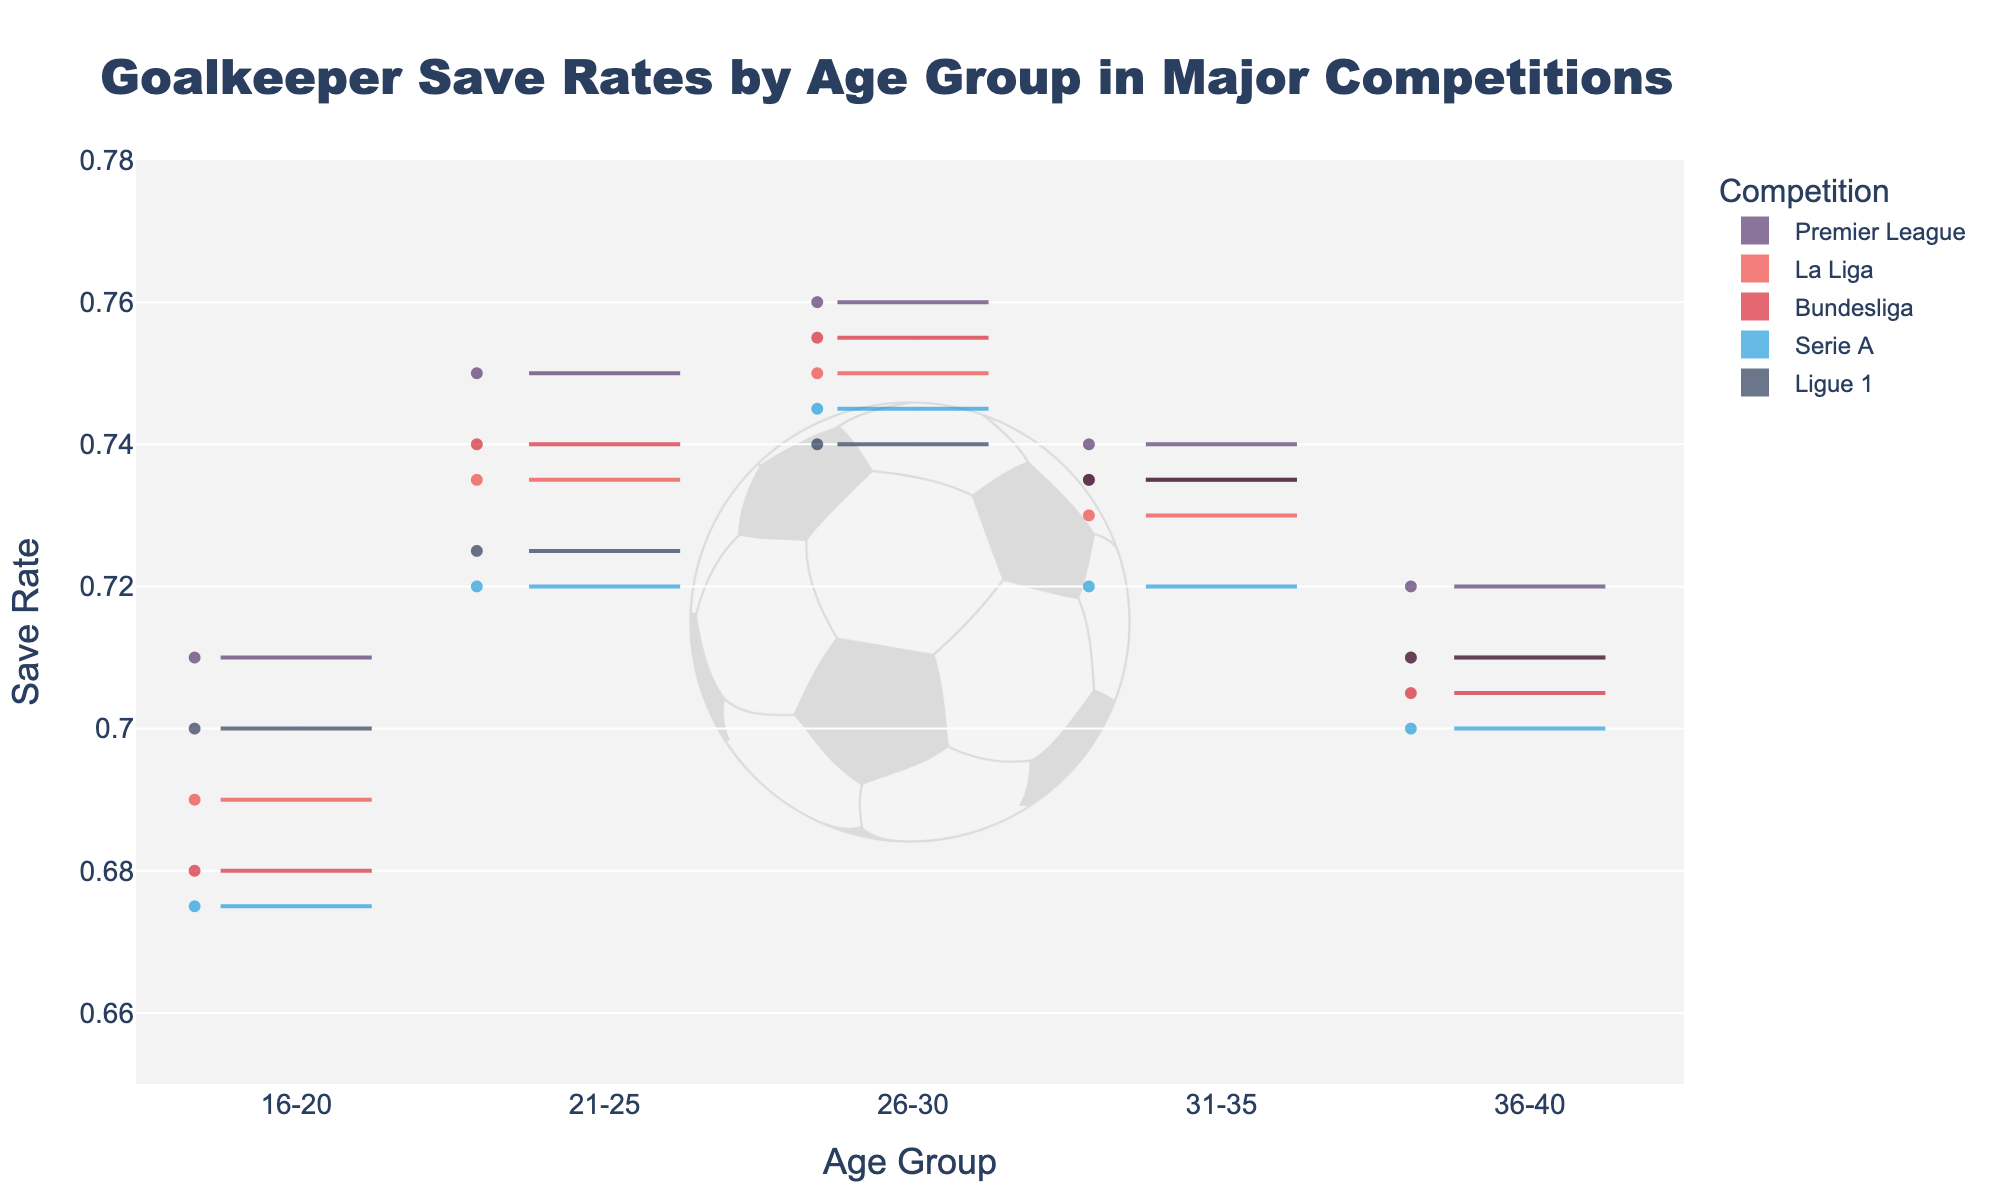What is the title of the figure? The title of the figure is located at the top center of the plot and provides a summary of what the plot represents. The text is bold and larger in size compared to other text elements.
Answer: Goalkeeper Save Rates by Age Group in Major Competitions What does the x-axis represent? The x-axis runs horizontally and is labeled towards the bottom of the plot, displaying different categories for grouping.
Answer: Age Group Which competition has the highest save rate in the age group 16-20? To find the highest save rate for the 16-20 age group, look at the points and meanlines within the 16-20 category and compare them across competitions.
Answer: Premier League What is the range of the y-axis? The y-axis runs vertically and is labeled along the left side of the plot. It shows the full scale of values represented in the plot, which can be seen in the y-axis ticks.
Answer: 0.65 to 0.78 How does the save rate trend differ between the 26-30 age group and the 36-40 age group for Premier League? Look at the Premier League violin plots for the age groups 26-30 and 36-40 and compare the central tendency (meanline) and distribution (spread of points).
Answer: 26-30 has higher save rates Which age group shows the most variability in save rates for Bundesliga? Variability can be assessed by looking at the spread of the data points in the violin plots for each age group in the Bundesliga category. The more spread out the points, the higher the variability.
Answer: 16-20 In which age group does Serie A show a higher save rate: 21-25 or 31-35? Compare the meanlines and points of the Serie A violin plots for the 21-25 and 31-35 age groups. The group with the higher meanline indicates a higher save rate.
Answer: 21-25 Which two age groups have the closest mean save rates for La Liga? Examine the meanlines for La Liga across all age groups. Identify which two meanlines are closest in value.
Answer: 31-35 and 36-40 Does Ligue 1 show an increasing or decreasing trend in save rates from age group 16-20 to 36-40? Observe the progression of meanlines in the Ligue 1 violin plots, from the left (younger age groups) to the right (older age groups), to determine if the save rates are generally increasing or decreasing.
Answer: Decreasing Which competition has the highest overall save rate across all age groups? To determine this, observe the meanlines for all competitions and identify which one consistently appears higher across all age groups. Compare their overall heights and their distribution peaks.
Answer: Premier League 